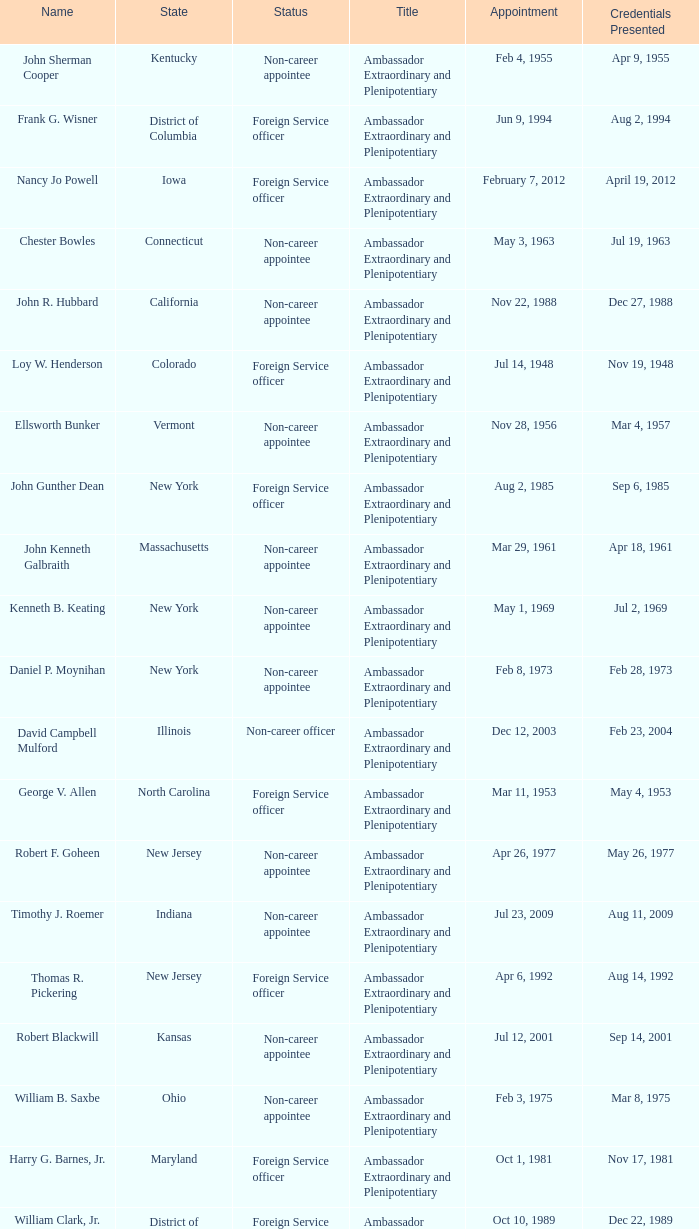What is the title for david campbell mulford? Ambassador Extraordinary and Plenipotentiary. 